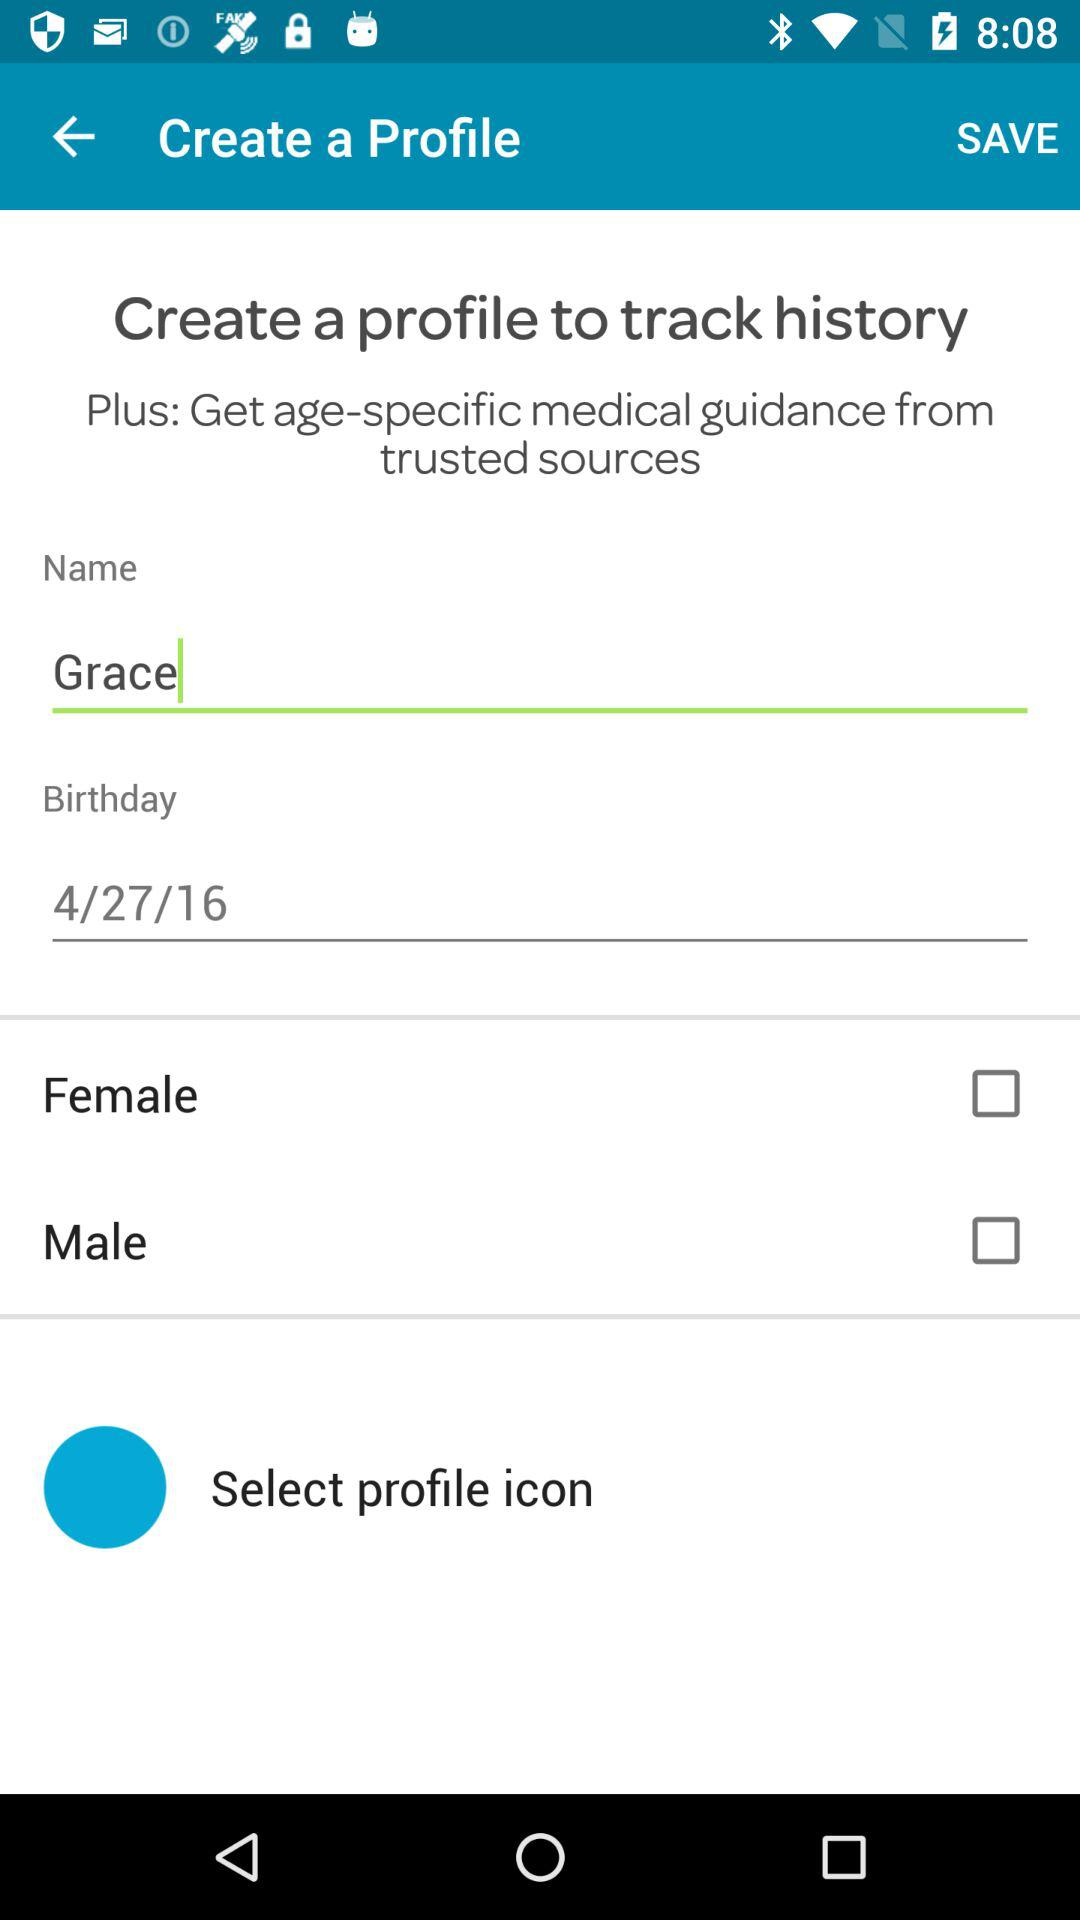What is the status of gender selected?
When the provided information is insufficient, respond with <no answer>. <no answer> 